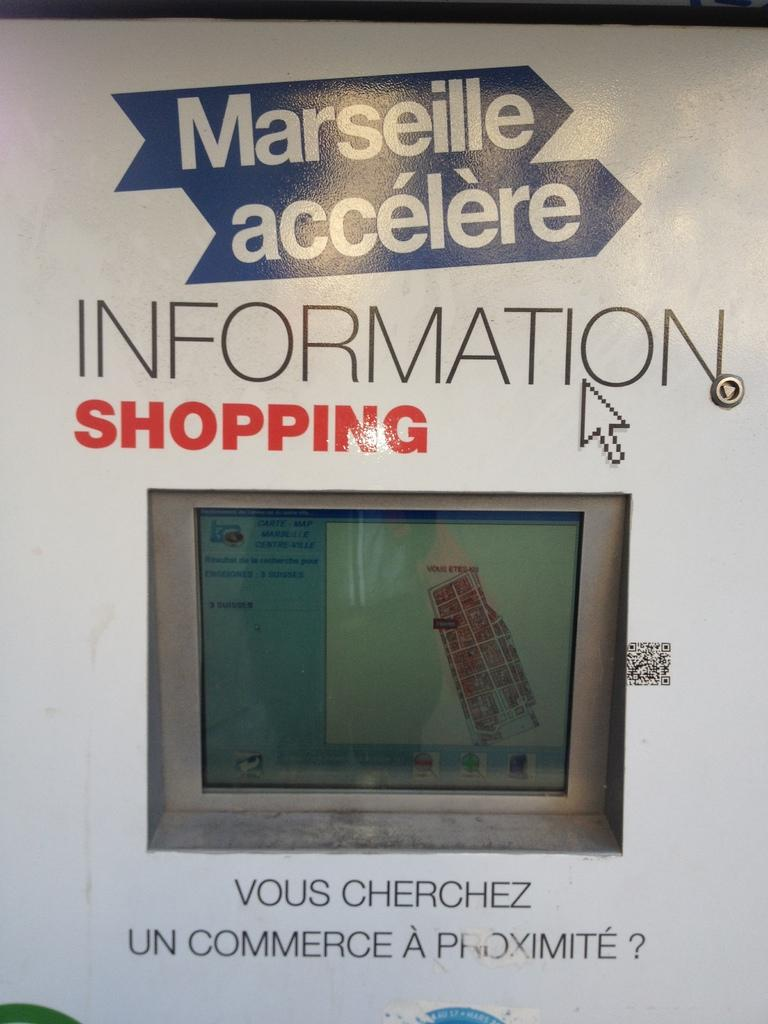<image>
Give a short and clear explanation of the subsequent image. An ad for a TV that says Information Shopping. 